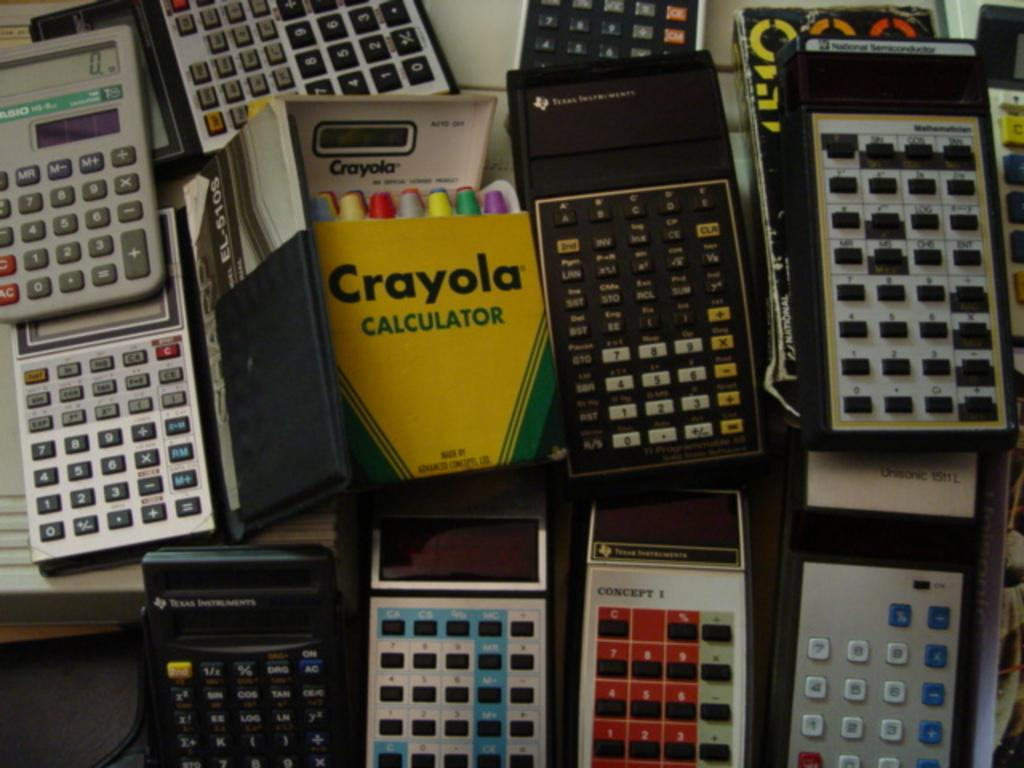<image>
Present a compact description of the photo's key features. A Crayola calculator sits in a pile of less colorful calculators. 